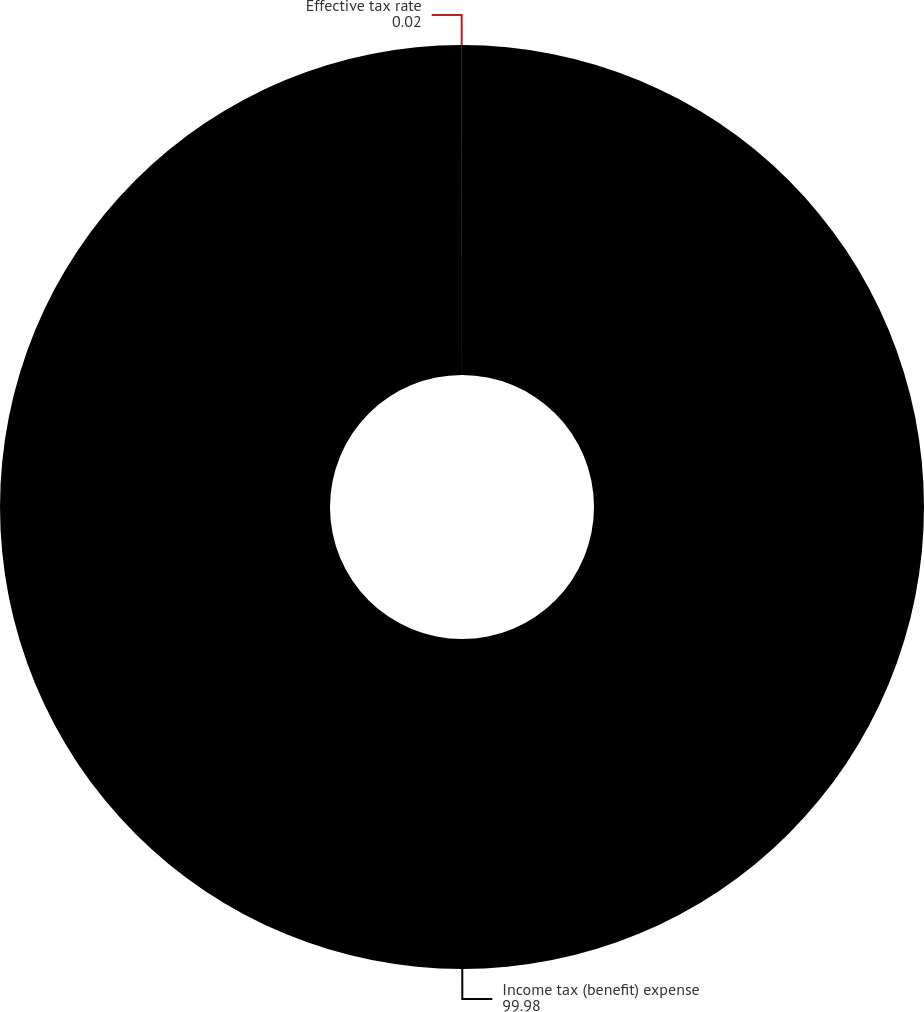Convert chart. <chart><loc_0><loc_0><loc_500><loc_500><pie_chart><fcel>Income tax (benefit) expense<fcel>Effective tax rate<nl><fcel>99.98%<fcel>0.02%<nl></chart> 